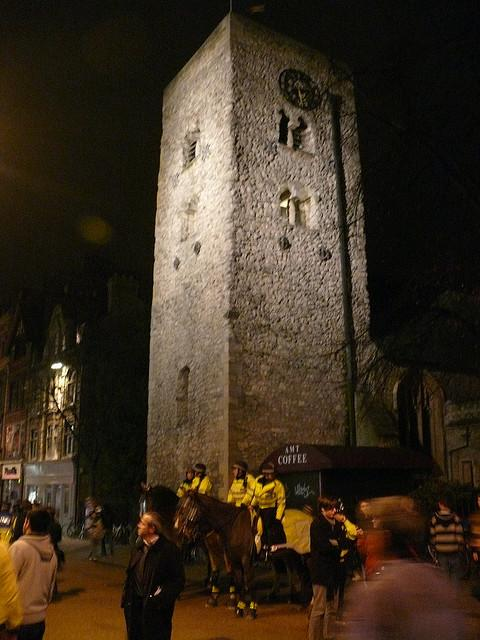What material composes this old square tower?

Choices:
A) brick
B) wood
C) cobblestone
D) mud cobblestone 